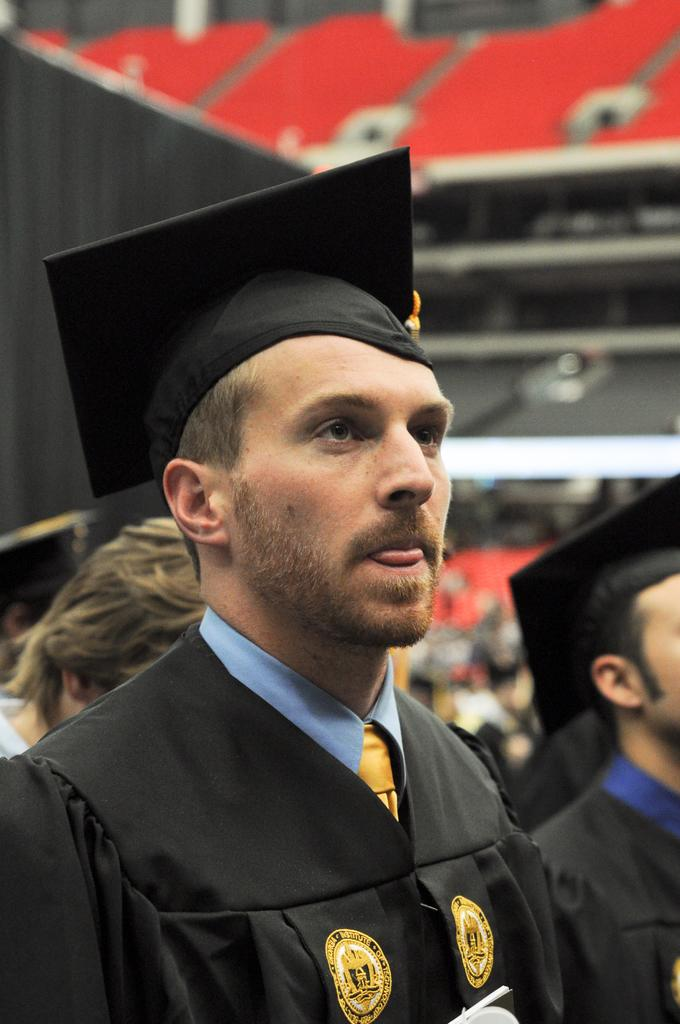How many persons are in academic dresses in the image? There are two persons in academic dresses in the image. Can you describe the head visible in the left corner of the image? The head of another person is visible in the left corner of the image. What can be said about the background of the image? The background of the image is blurred. What type of skin is visible on the pan in the image? There is no pan or skin present in the image. What color is the silver object in the image? There is no silver object present in the image. 